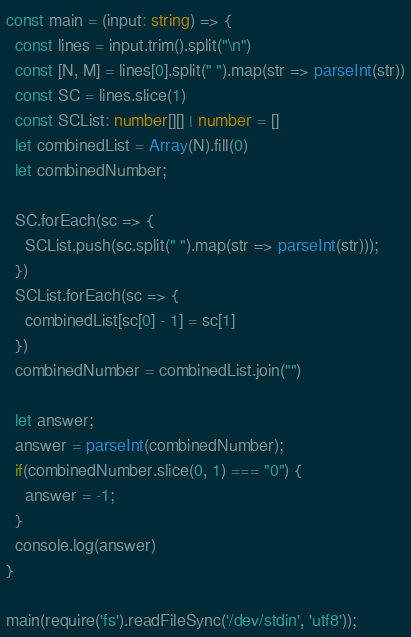<code> <loc_0><loc_0><loc_500><loc_500><_TypeScript_>const main = (input: string) => {
  const lines = input.trim().split("\n")
  const [N, M] = lines[0].split(" ").map(str => parseInt(str))
  const SC = lines.slice(1)
  const SCList: number[][] | number = []
  let combinedList = Array(N).fill(0)
  let combinedNumber;

  SC.forEach(sc => {
    SCList.push(sc.split(" ").map(str => parseInt(str)));
  })
  SCList.forEach(sc => {
    combinedList[sc[0] - 1] = sc[1]
  })
  combinedNumber = combinedList.join("")

  let answer;
  answer = parseInt(combinedNumber);
  if(combinedNumber.slice(0, 1) === "0") {
    answer = -1;
  }
  console.log(answer)
}

main(require('fs').readFileSync('/dev/stdin', 'utf8'));
</code> 